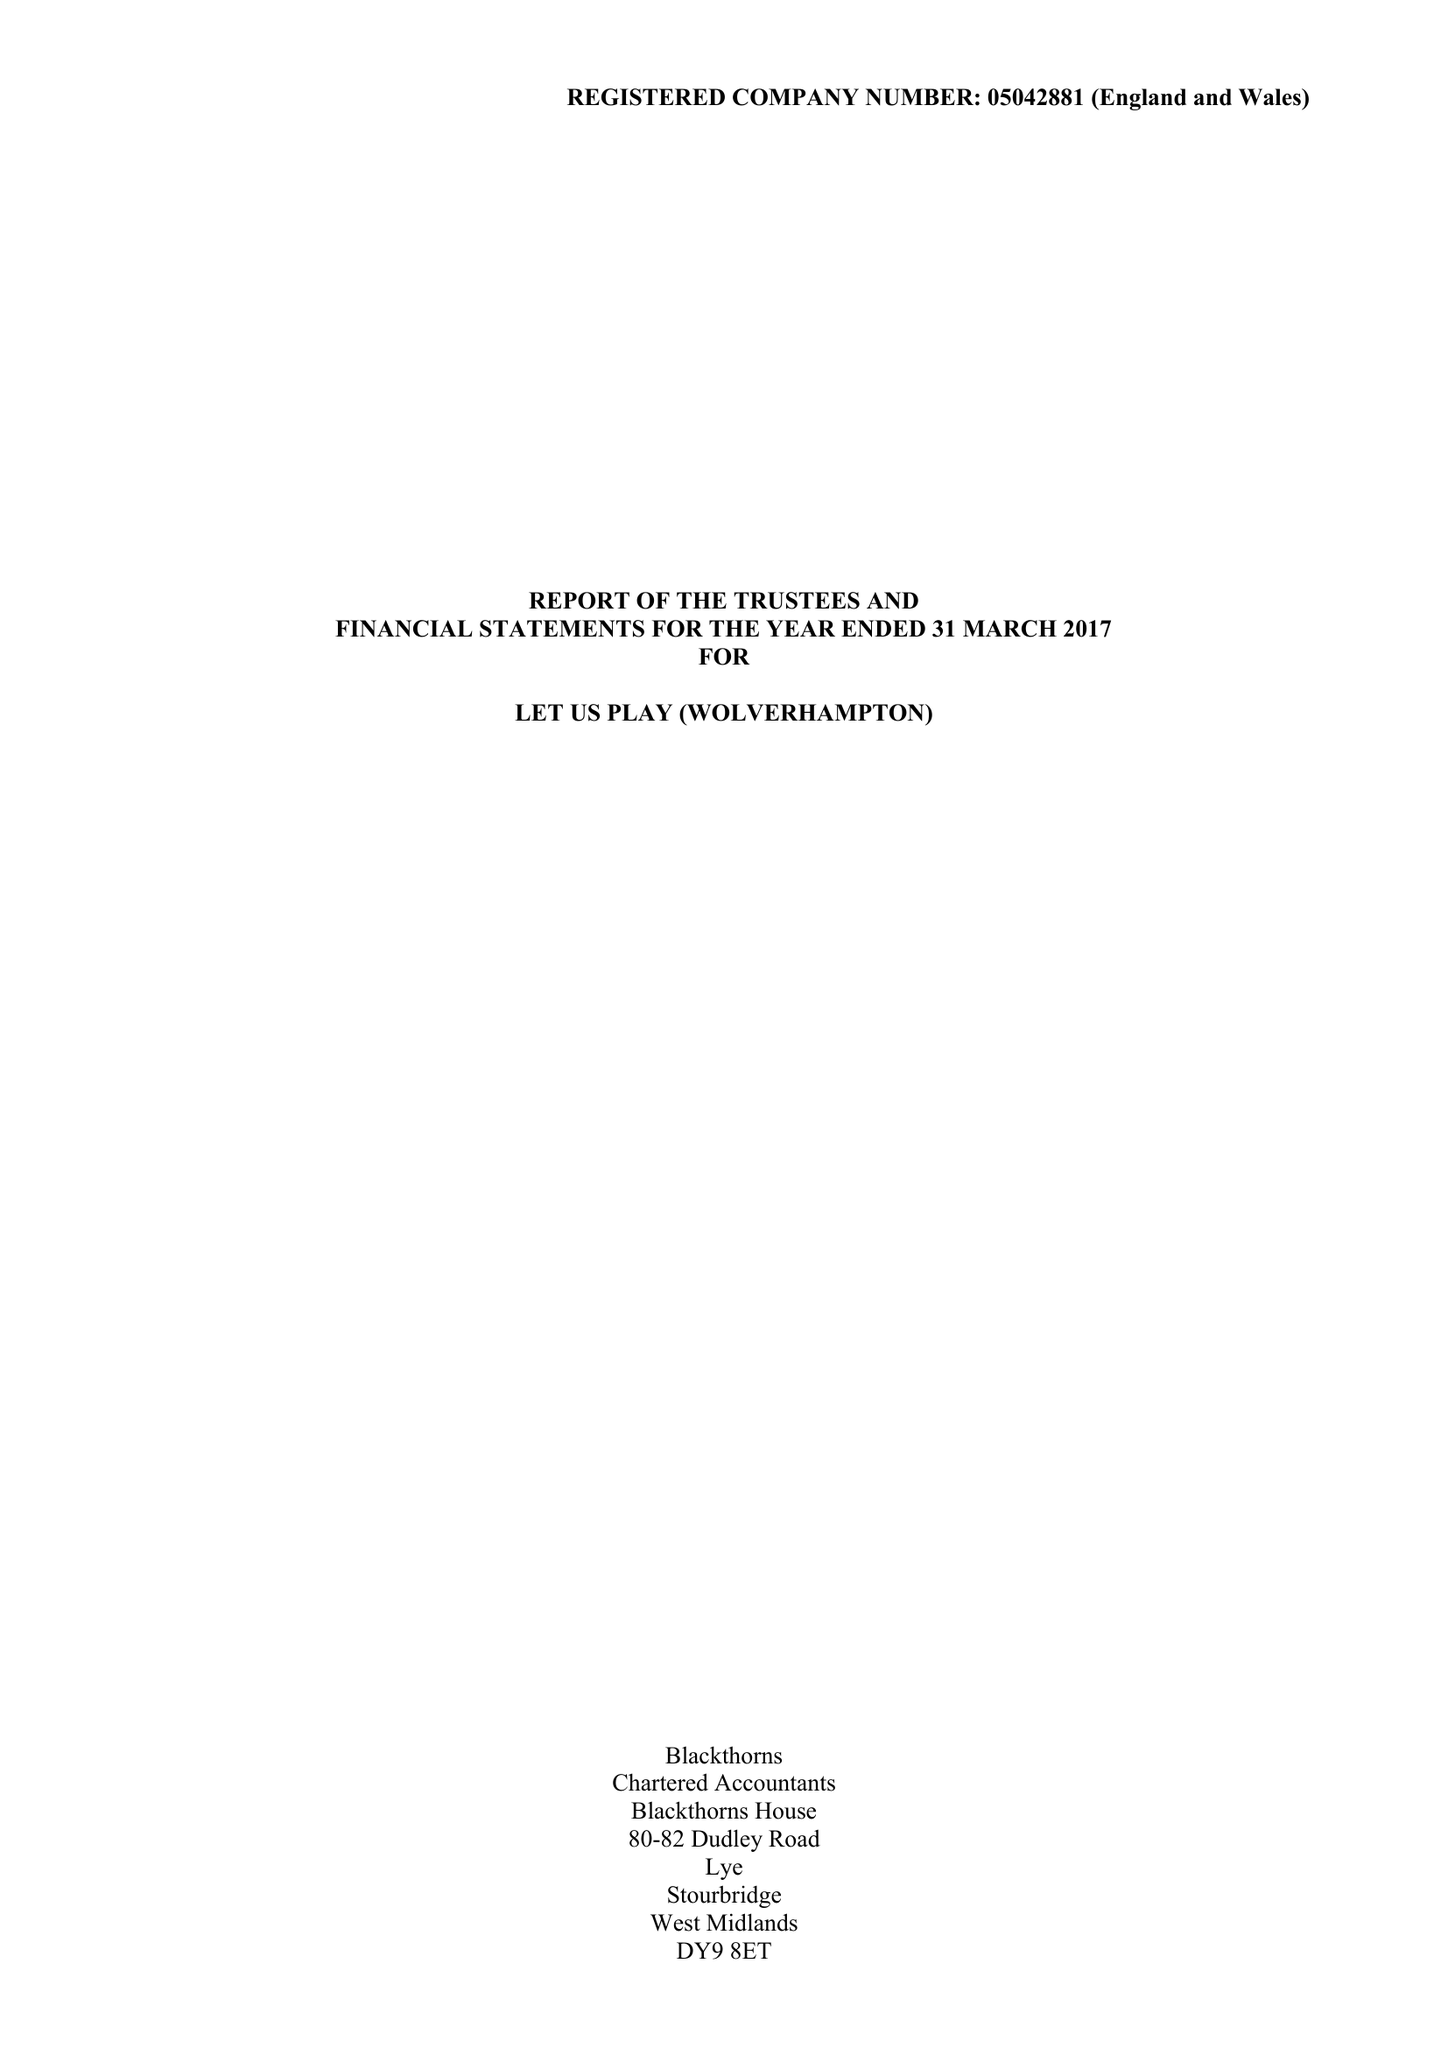What is the value for the income_annually_in_british_pounds?
Answer the question using a single word or phrase. 158856.00 